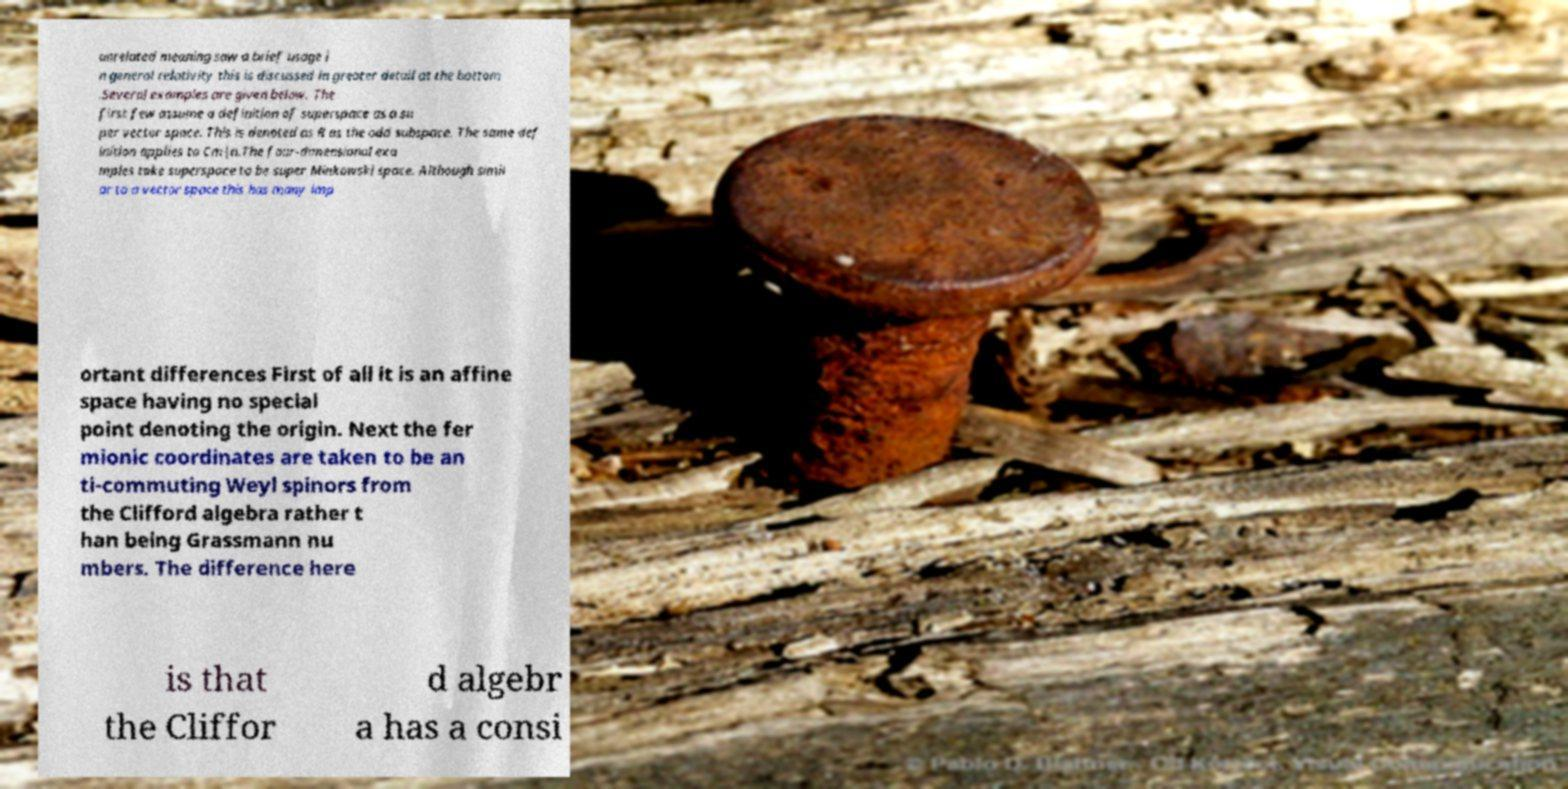For documentation purposes, I need the text within this image transcribed. Could you provide that? unrelated meaning saw a brief usage i n general relativity this is discussed in greater detail at the bottom .Several examples are given below. The first few assume a definition of superspace as a su per vector space. This is denoted as R as the odd subspace. The same def inition applies to Cm|n.The four-dimensional exa mples take superspace to be super Minkowski space. Although simil ar to a vector space this has many imp ortant differences First of all it is an affine space having no special point denoting the origin. Next the fer mionic coordinates are taken to be an ti-commuting Weyl spinors from the Clifford algebra rather t han being Grassmann nu mbers. The difference here is that the Cliffor d algebr a has a consi 